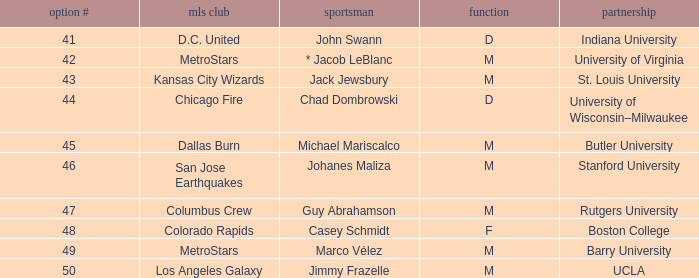What team does Jimmy Frazelle play on? Los Angeles Galaxy. 